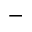<formula> <loc_0><loc_0><loc_500><loc_500>-</formula> 